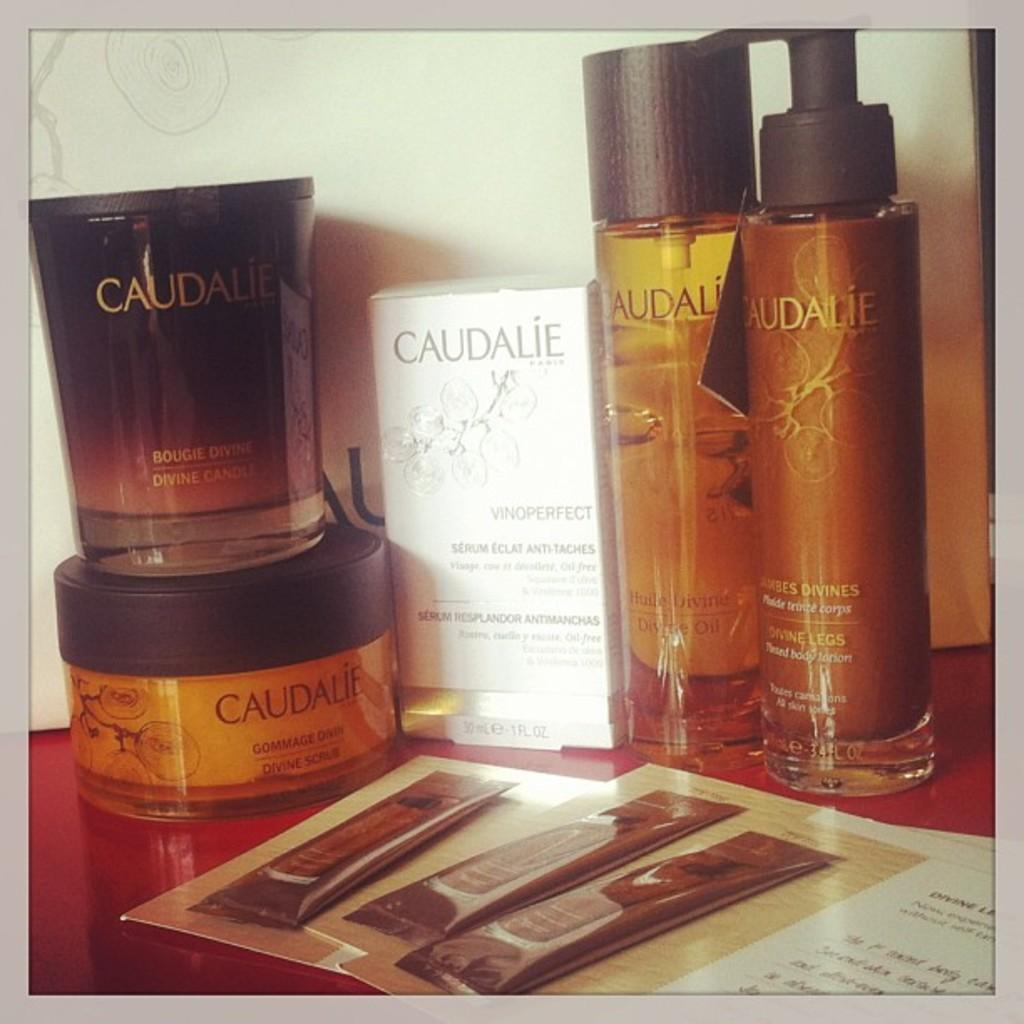Provide a one-sentence caption for the provided image. Caudalie branded bottles and containers are on display. 